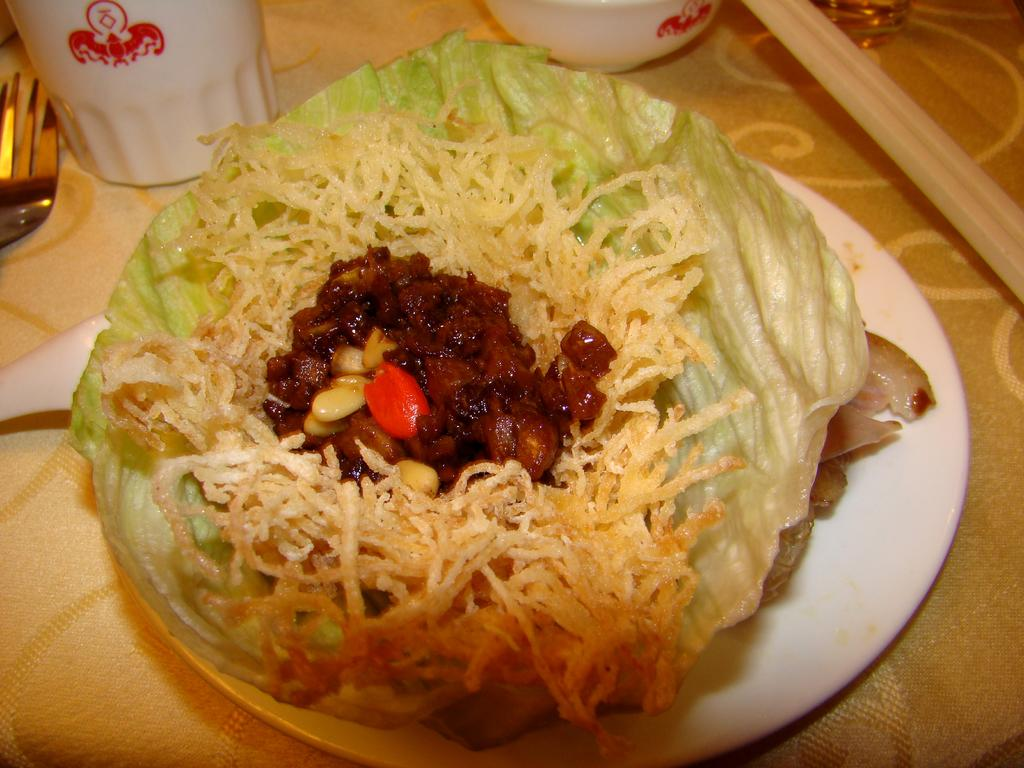What object is present in the image that can hold food? There is a plate in the image that can hold food. What is on the plate in the image? There is food on the plate in the image. What object is present in the image that can hold a beverage? There is a glass in the image that can hold a beverage. What utensil is present in the image? There is a fork in the image. What is under the plate in the image? There is a cloth under the plate in the image. How many cannons are visible in the image? There are no cannons present in the image. What type of corn is being served on the plate in the image? There is no corn present on the plate in the image. 